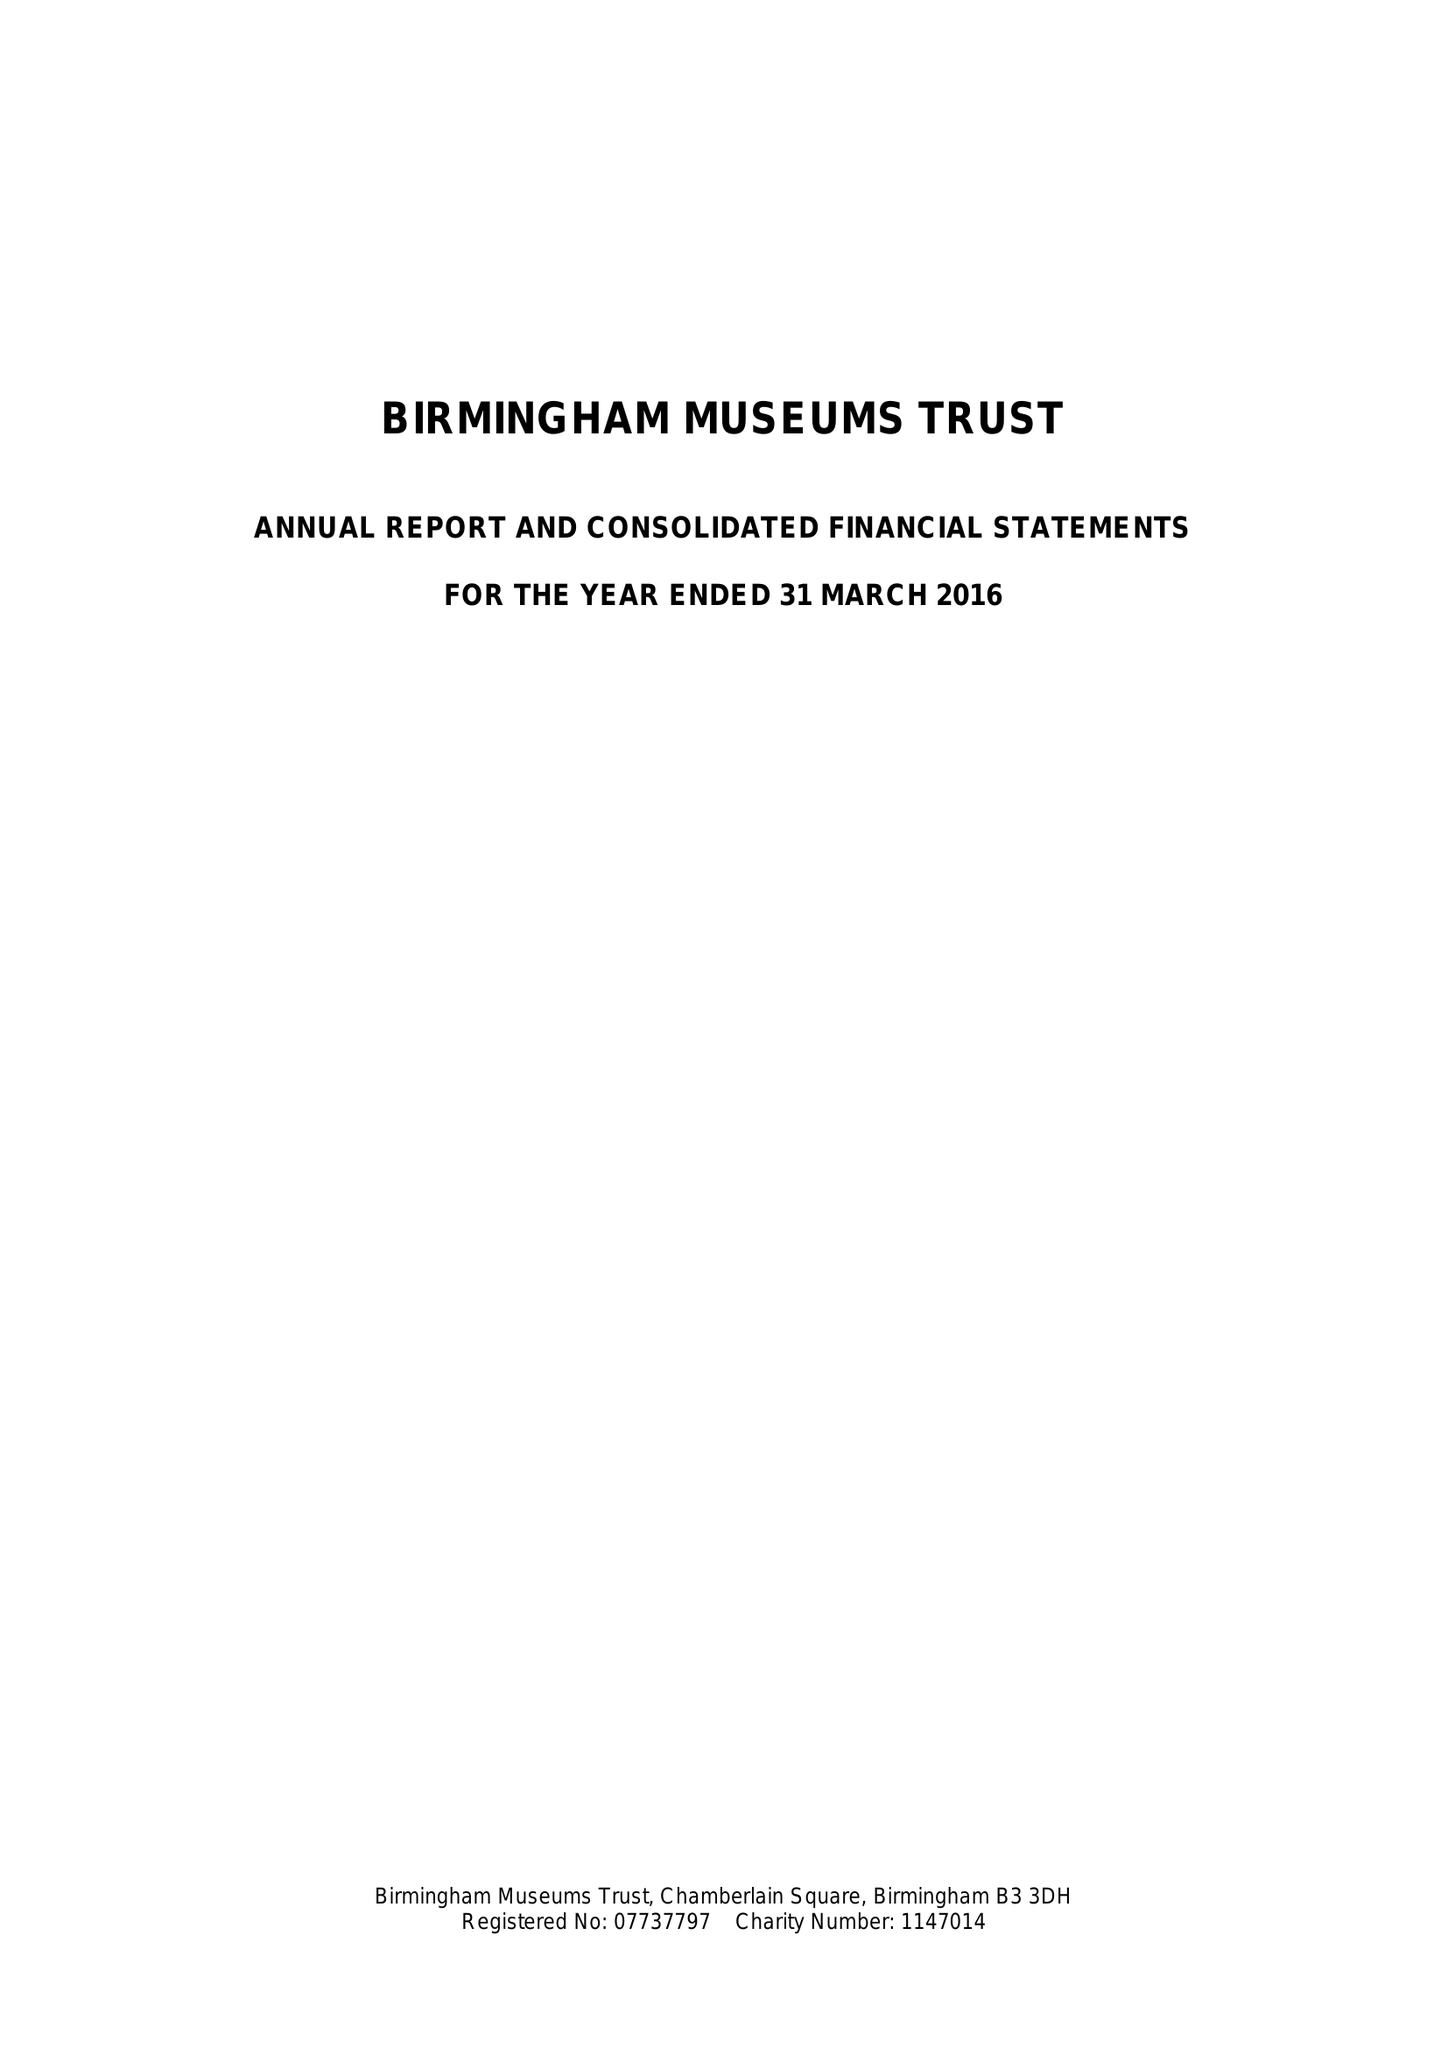What is the value for the address__street_line?
Answer the question using a single word or phrase. None 